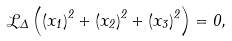Convert formula to latex. <formula><loc_0><loc_0><loc_500><loc_500>\mathcal { L } _ { \Delta } \left ( \left ( x _ { 1 } \right ) ^ { 2 } + \left ( x _ { 2 } \right ) ^ { 2 } + \left ( x _ { 3 } \right ) ^ { 2 } \right ) = 0 ,</formula> 